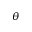<formula> <loc_0><loc_0><loc_500><loc_500>\theta</formula> 